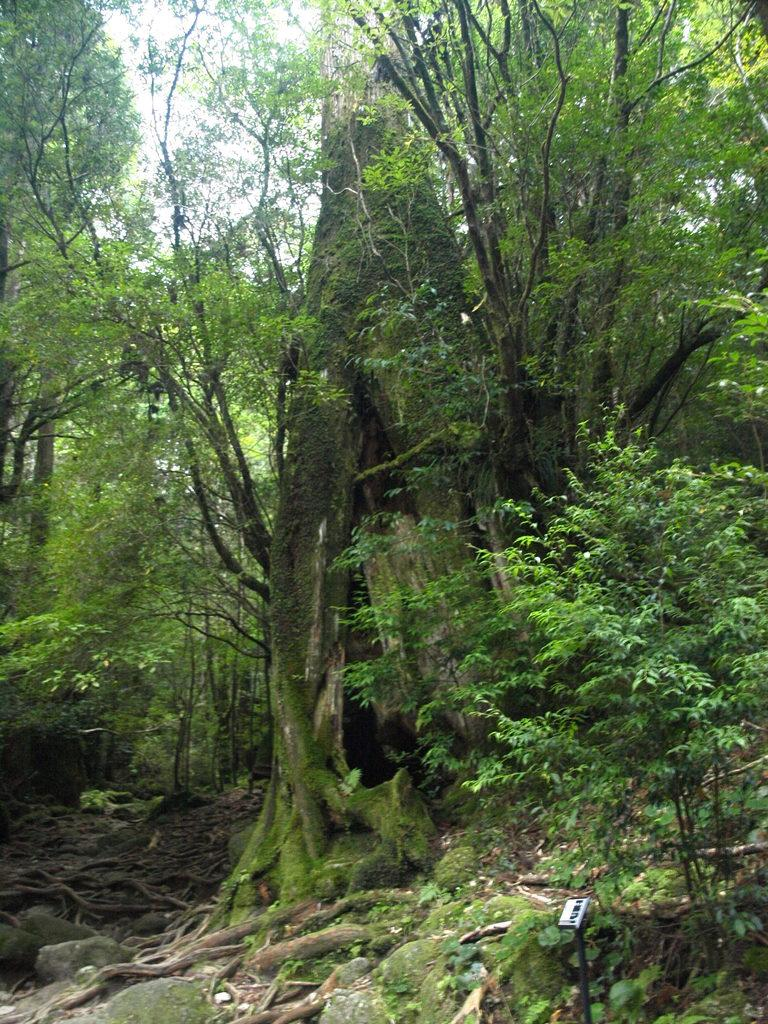What type of vegetation can be seen in the image? There are plants and trees in the image. What other objects are present in the image besides vegetation? There are rocks in the image. What can be seen in the background of the image? The sky is visible in the background of the image. What type of milk can be seen coming from the rocks in the image? There is no milk present in the image; it features plants, trees, rocks, and the sky. 